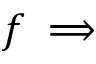<formula> <loc_0><loc_0><loc_500><loc_500>f \implies</formula> 